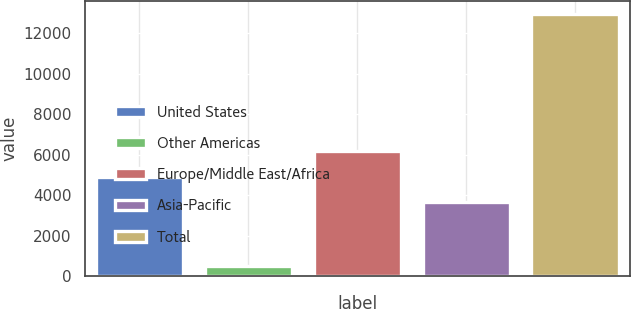<chart> <loc_0><loc_0><loc_500><loc_500><bar_chart><fcel>United States<fcel>Other Americas<fcel>Europe/Middle East/Africa<fcel>Asia-Pacific<fcel>Total<nl><fcel>4923.5<fcel>514<fcel>6168<fcel>3679<fcel>12959<nl></chart> 